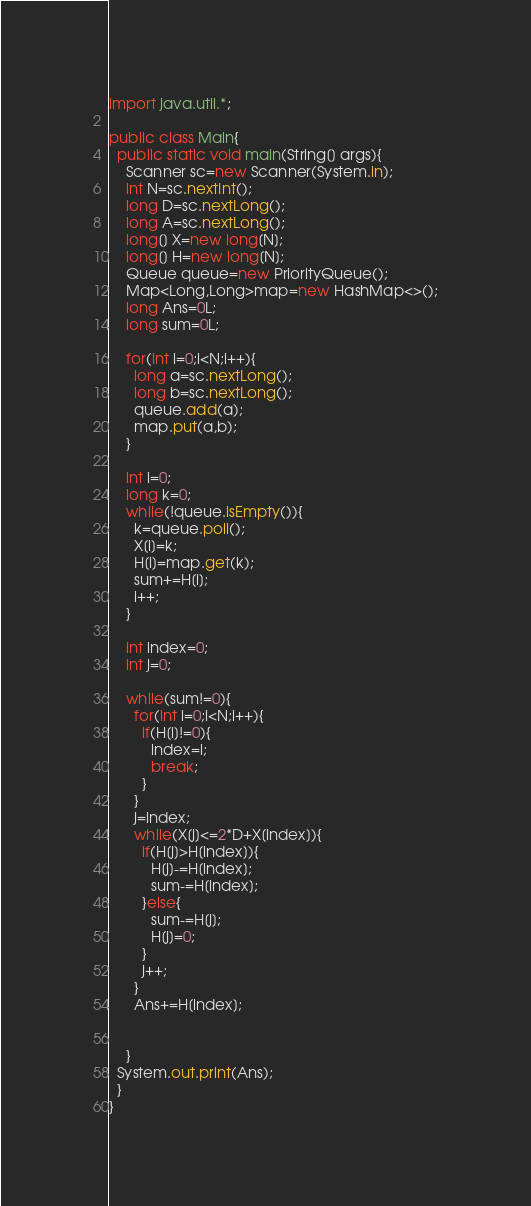Convert code to text. <code><loc_0><loc_0><loc_500><loc_500><_Java_>import java.util.*;

public class Main{
  public static void main(String[] args){
	Scanner sc=new Scanner(System.in);
	int N=sc.nextInt();
    long D=sc.nextLong();
    long A=sc.nextLong();
    long[] X=new long[N];
    long[] H=new long[N];
	Queue queue=new PriorityQueue();
    Map<Long,Long>map=new HashMap<>();
    long Ans=0L;
    long sum=0L;
    
    for(int i=0;i<N;i++){
      long a=sc.nextLong();
      long b=sc.nextLong();
	  queue.add(a);
      map.put(a,b);
    }
    
    int i=0;
    long k=0;
    while(!queue.isEmpty()){
      k=queue.poll();
      X[i]=k;
      H[i]=map.get(k);
      sum+=H[i];
      i++;
    }
    
    int index=0;
    int j=0;
    
    while(sum!=0){
      for(int i=0;i<N;i++){
        if(H[i]!=0){
          index=i;
          break;
        }
      }
      j=index;
      while(X[j]<=2*D+X[index]){
        if(H[j]>H[index]){
          H[j]-=H[index];
          sum-=H[index];
        }else{
          sum-=H[j];
          H[j]=0;
        }
        j++;
      }
      Ans+=H[index];
      
      
    }
  System.out.print(Ans);
  }
}</code> 